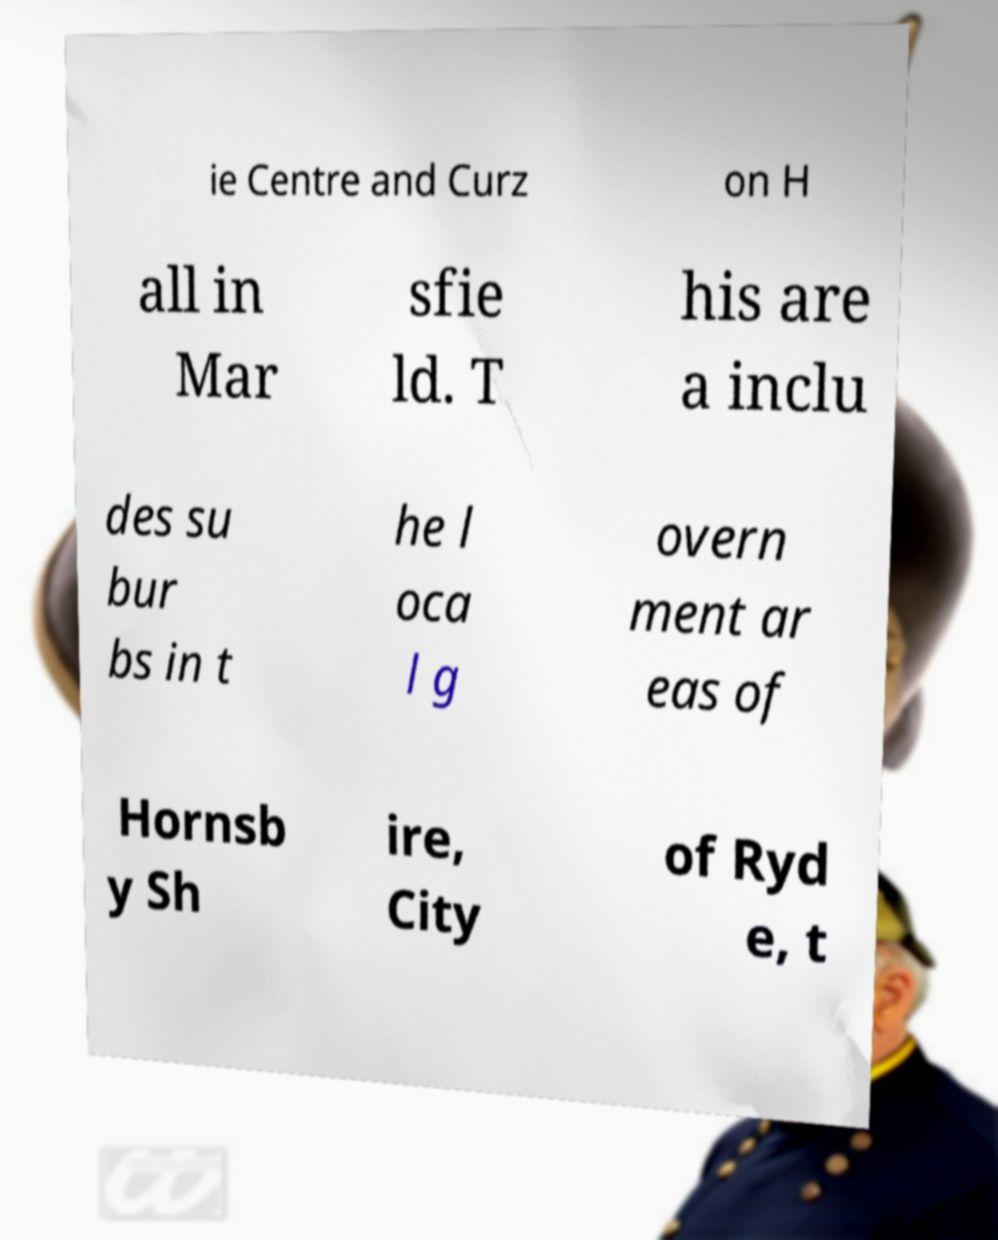What messages or text are displayed in this image? I need them in a readable, typed format. ie Centre and Curz on H all in Mar sfie ld. T his are a inclu des su bur bs in t he l oca l g overn ment ar eas of Hornsb y Sh ire, City of Ryd e, t 